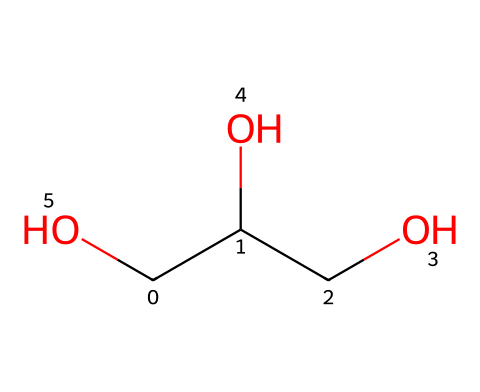What is the name of this chemical? The SMILES representation indicates a 3-carbon alcohol with hydroxyl groups, which corresponds to glycerol.
Answer: glycerol How many carbon atoms are present in the structure? Counting the 'C' symbols in the SMILES notation shows that there are three carbon atoms in total.
Answer: three How many hydroxyl (–OH) groups does glycerol have? In the structural formula represented by the SMILES, there are three 'O' atoms, each corresponding to a hydroxyl group, making three in total.
Answer: three What type of functional groups are present in glycerol? The presence of the 'O' atoms bonded to hydrogen atoms indicates the presence of alcohol functional groups (–OH).
Answer: alcohol What is the molecular formula of glycerol? The number of each type of atom based on the SMILES is 3 carbons, 8 hydrogens, and 3 oxygens, leading to the formula C3H8O3.
Answer: C3H8O3 Is glycerol a solid, liquid, or gas at room temperature? Glycerol is a liquid due to its molecular structure, which allows it to remain in a fluid state at room temperature.
Answer: liquid What is the primary use of glycerol in food? Glycerol primarily acts as a preservative and humectant, helping to retain moisture in food products.
Answer: preservative 